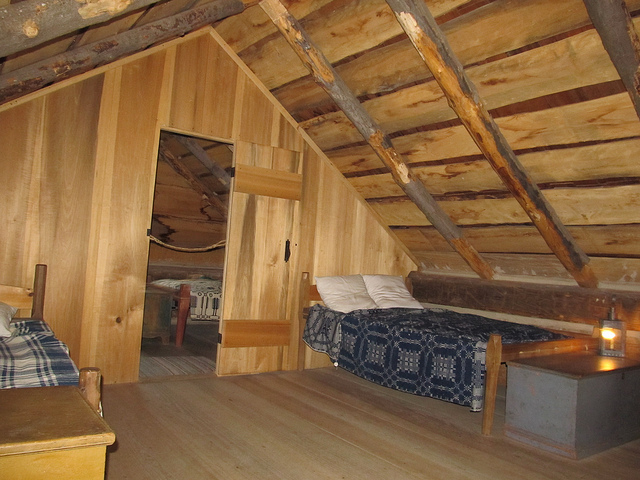How many beds can be seen? There are two beds visible in this rustic attic room. One is immediately noticeable with a blue and white duvet and a pillow, placed to the right under the sloping roof. The other bed is partially obscured by a wooden partition, with a hint of its patterned bedding visible in the semi-hidden space. 